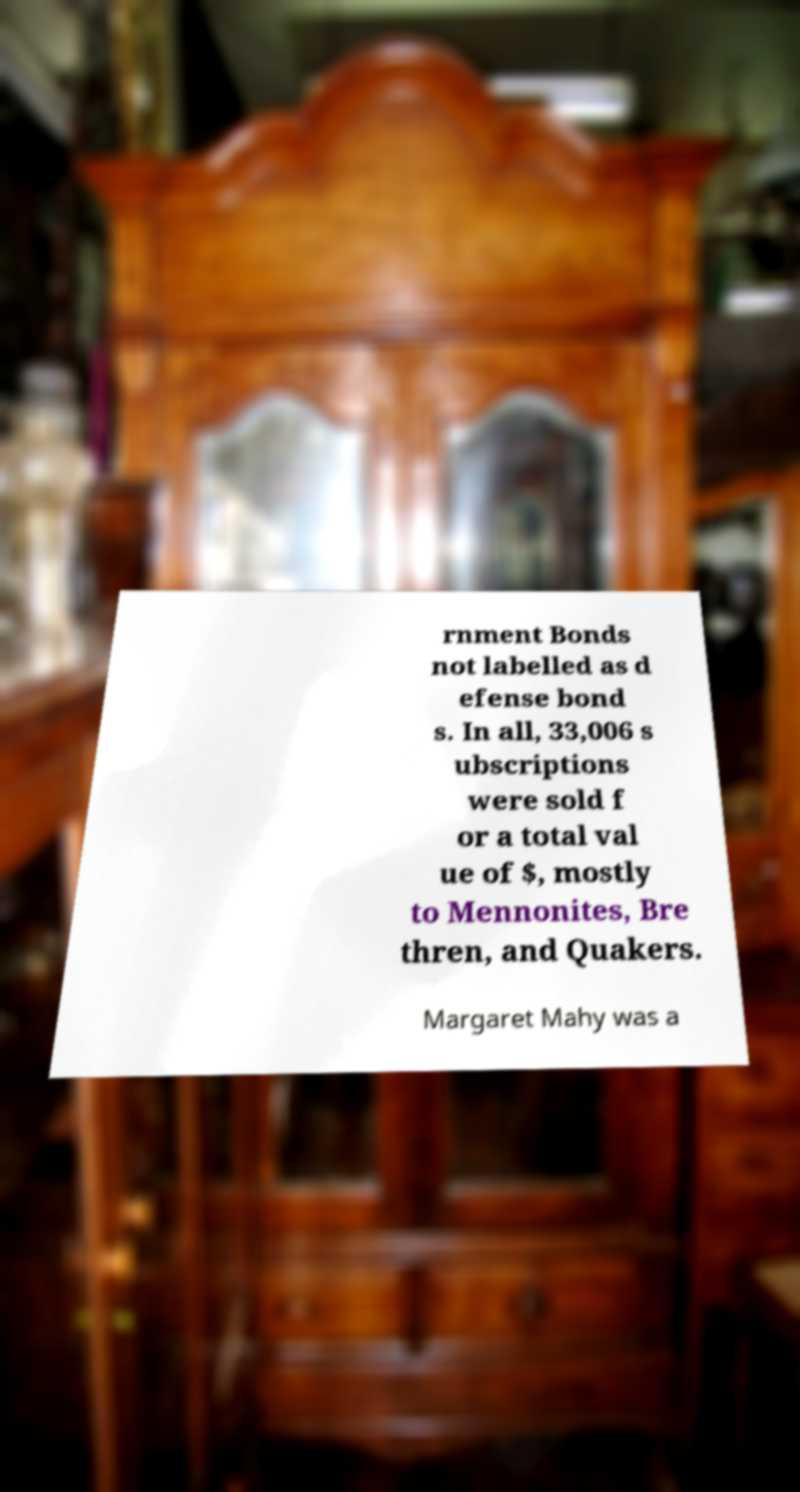Could you extract and type out the text from this image? rnment Bonds not labelled as d efense bond s. In all, 33,006 s ubscriptions were sold f or a total val ue of $, mostly to Mennonites, Bre thren, and Quakers. Margaret Mahy was a 